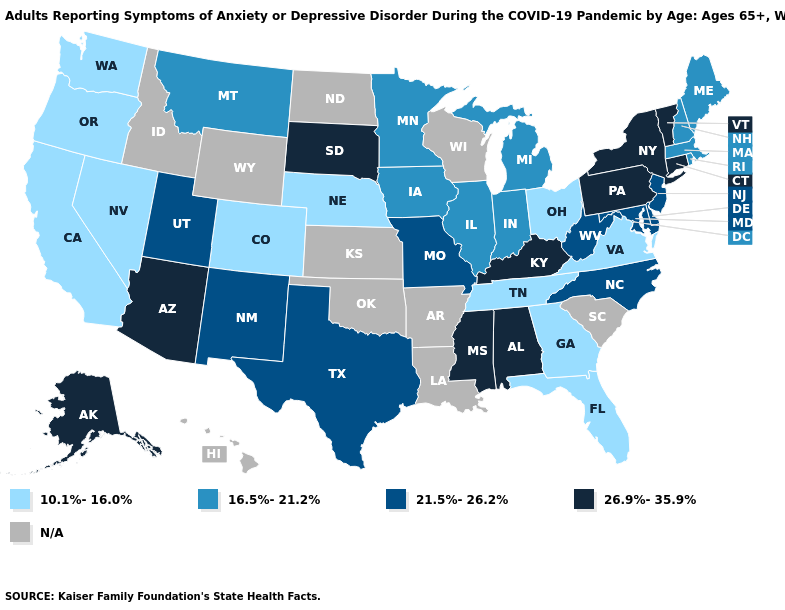Is the legend a continuous bar?
Give a very brief answer. No. What is the value of Ohio?
Write a very short answer. 10.1%-16.0%. Does the map have missing data?
Write a very short answer. Yes. What is the value of Minnesota?
Quick response, please. 16.5%-21.2%. What is the value of Oregon?
Short answer required. 10.1%-16.0%. Which states have the lowest value in the MidWest?
Give a very brief answer. Nebraska, Ohio. Among the states that border Arizona , which have the lowest value?
Be succinct. California, Colorado, Nevada. How many symbols are there in the legend?
Be succinct. 5. Name the states that have a value in the range 26.9%-35.9%?
Quick response, please. Alabama, Alaska, Arizona, Connecticut, Kentucky, Mississippi, New York, Pennsylvania, South Dakota, Vermont. Does Michigan have the lowest value in the MidWest?
Keep it brief. No. Does Indiana have the highest value in the USA?
Quick response, please. No. What is the value of Indiana?
Answer briefly. 16.5%-21.2%. 